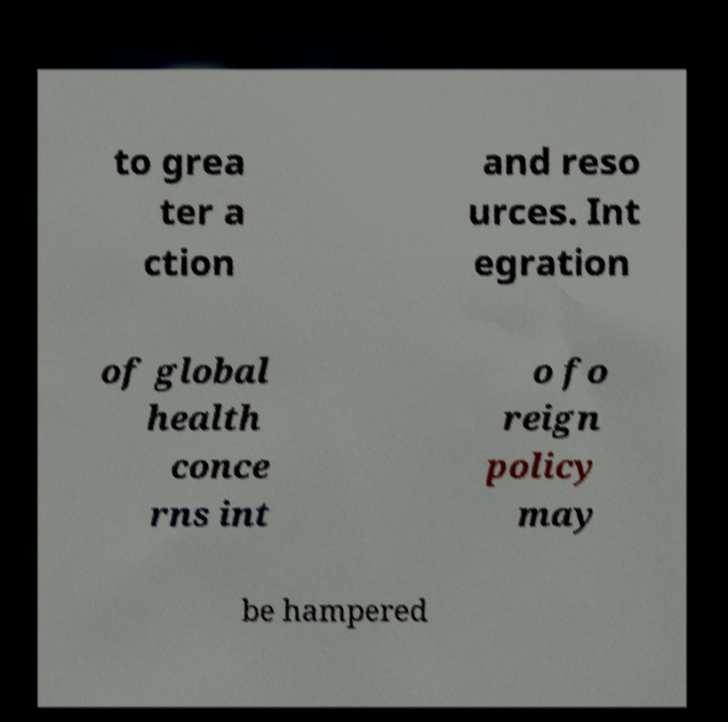Could you extract and type out the text from this image? to grea ter a ction and reso urces. Int egration of global health conce rns int o fo reign policy may be hampered 